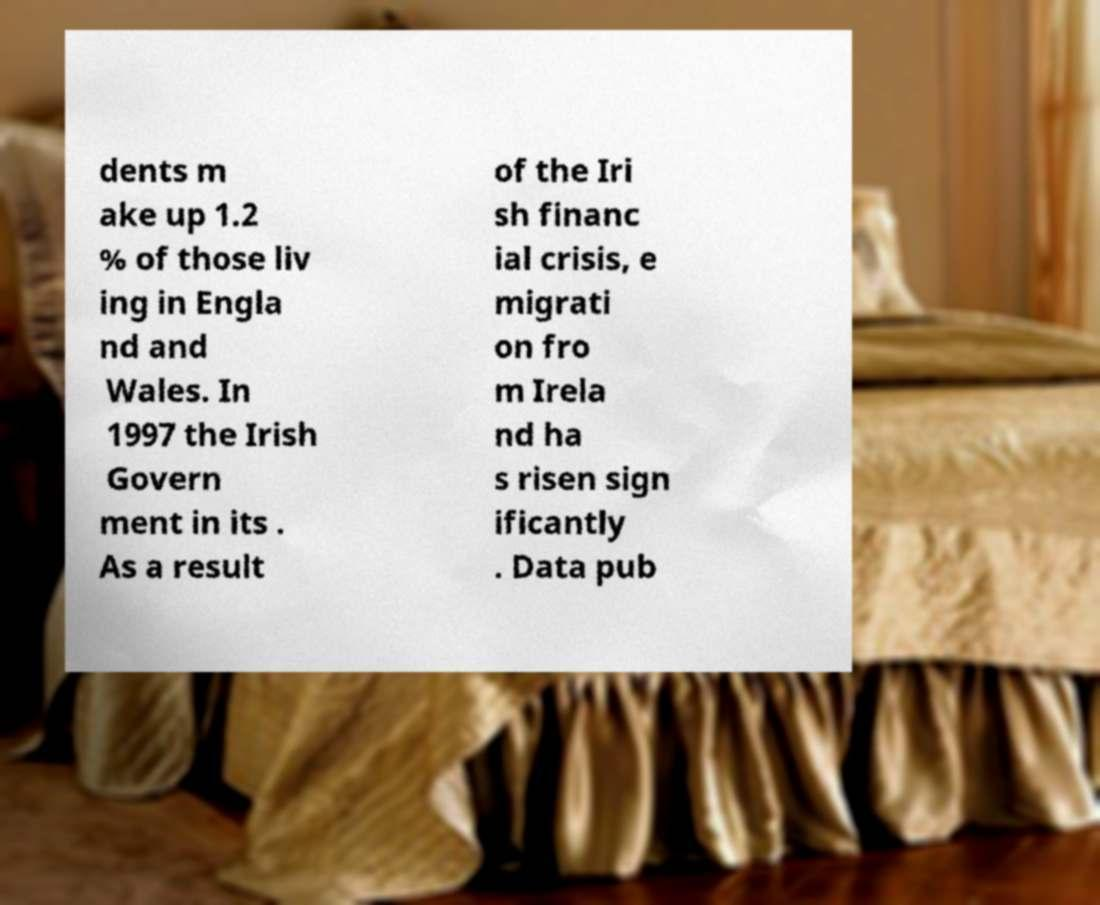For documentation purposes, I need the text within this image transcribed. Could you provide that? dents m ake up 1.2 % of those liv ing in Engla nd and Wales. In 1997 the Irish Govern ment in its . As a result of the Iri sh financ ial crisis, e migrati on fro m Irela nd ha s risen sign ificantly . Data pub 